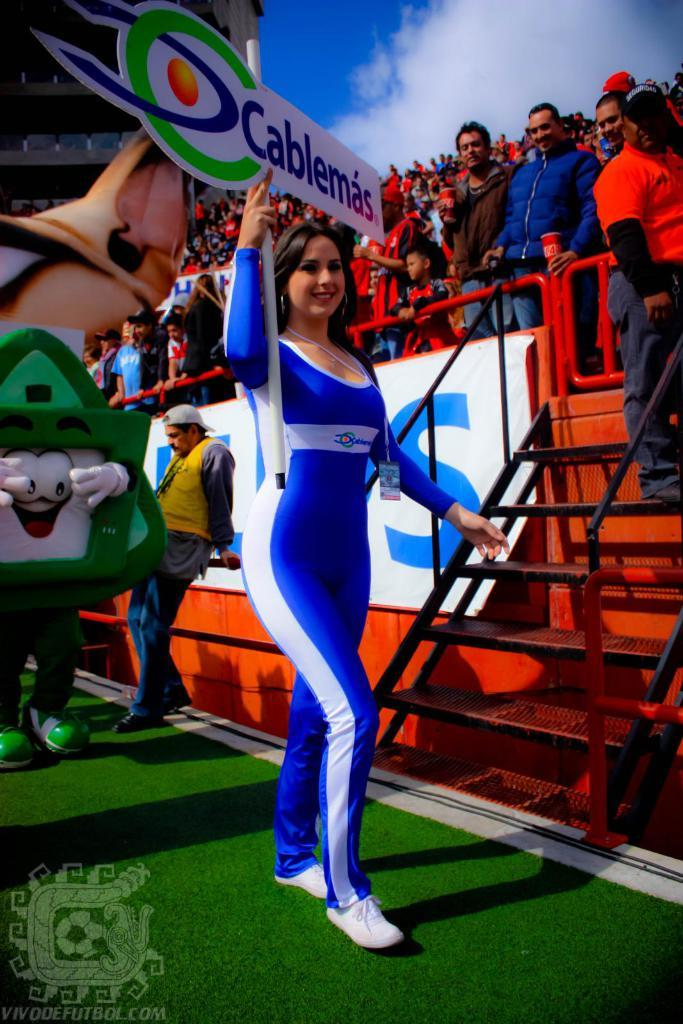Provide a one-sentence caption for the provided image. The girl carrying the Cablemas sign is wearing a blue jumpsuit. 